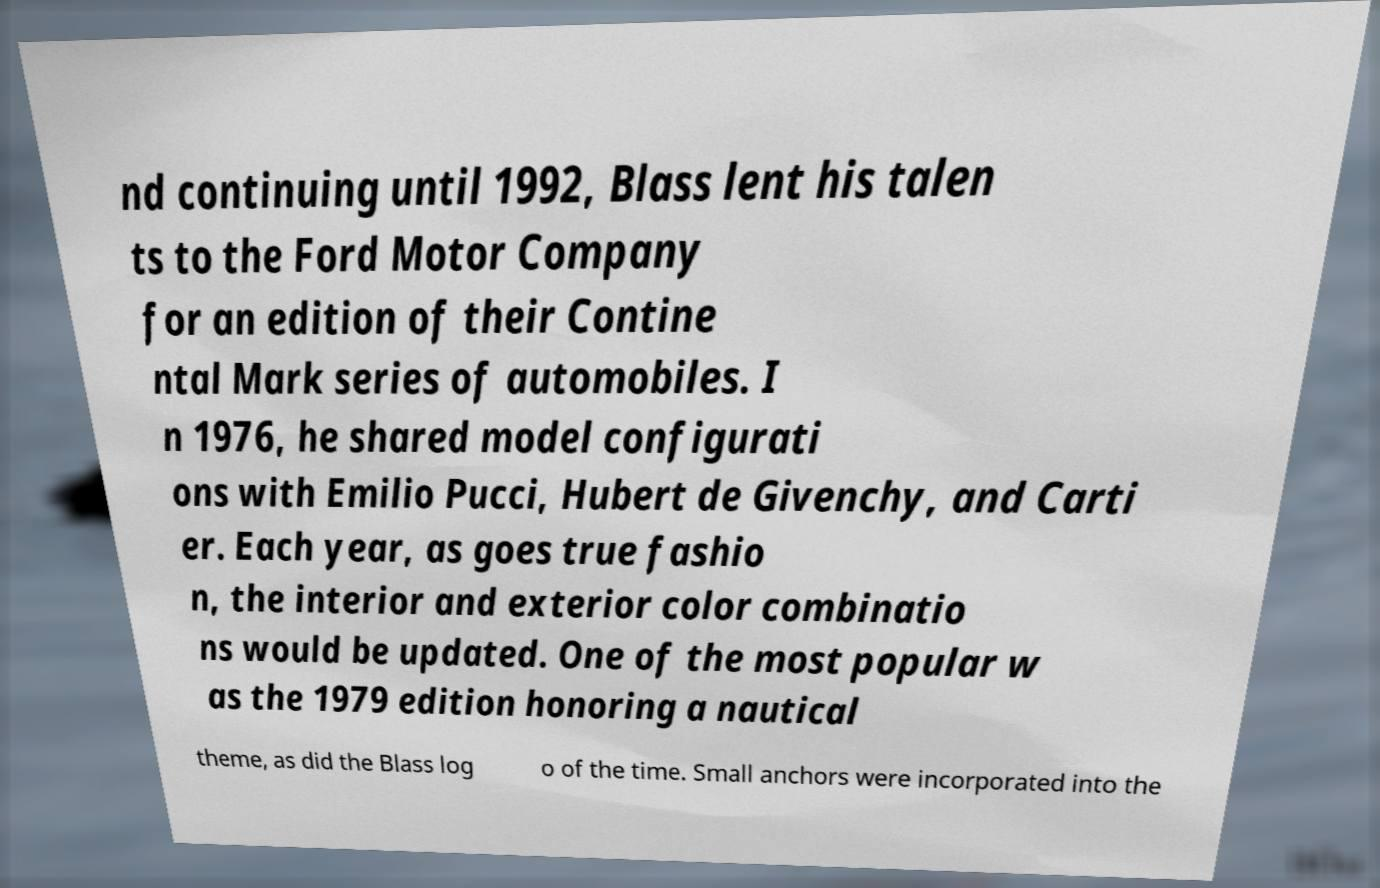What messages or text are displayed in this image? I need them in a readable, typed format. nd continuing until 1992, Blass lent his talen ts to the Ford Motor Company for an edition of their Contine ntal Mark series of automobiles. I n 1976, he shared model configurati ons with Emilio Pucci, Hubert de Givenchy, and Carti er. Each year, as goes true fashio n, the interior and exterior color combinatio ns would be updated. One of the most popular w as the 1979 edition honoring a nautical theme, as did the Blass log o of the time. Small anchors were incorporated into the 